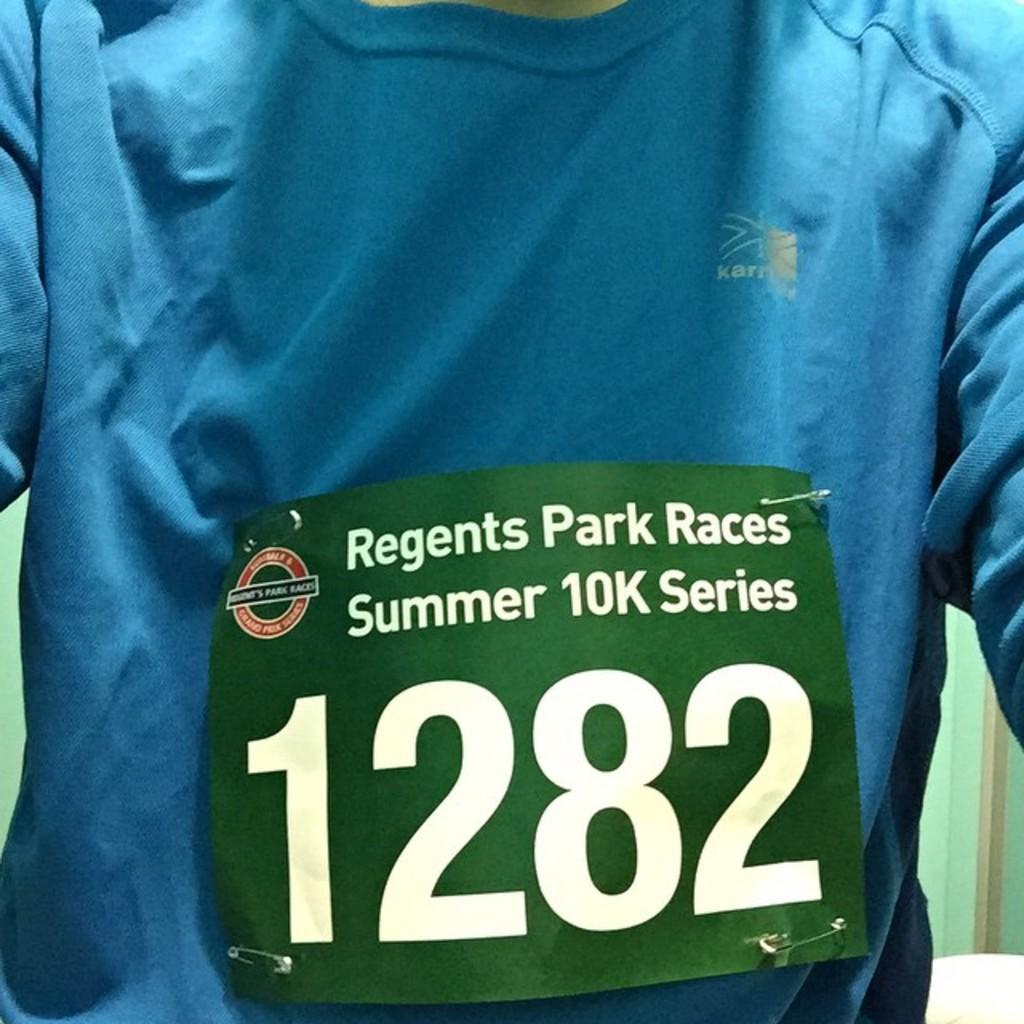What is the name of the town?
Provide a short and direct response. Regents park. 